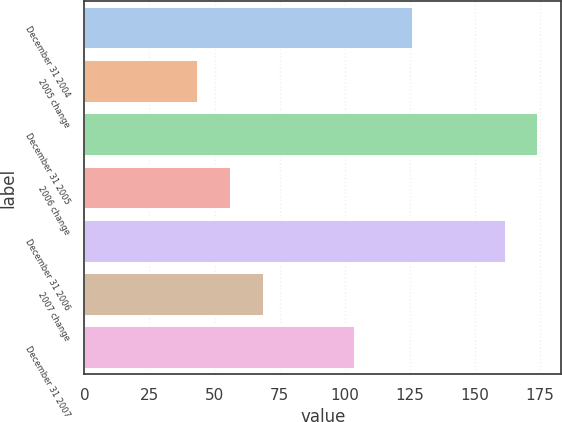Convert chart. <chart><loc_0><loc_0><loc_500><loc_500><bar_chart><fcel>December 31 2004<fcel>2005 change<fcel>December 31 2005<fcel>2006 change<fcel>December 31 2006<fcel>2007 change<fcel>December 31 2007<nl><fcel>126.3<fcel>43.6<fcel>174.53<fcel>56.23<fcel>161.9<fcel>68.86<fcel>104<nl></chart> 